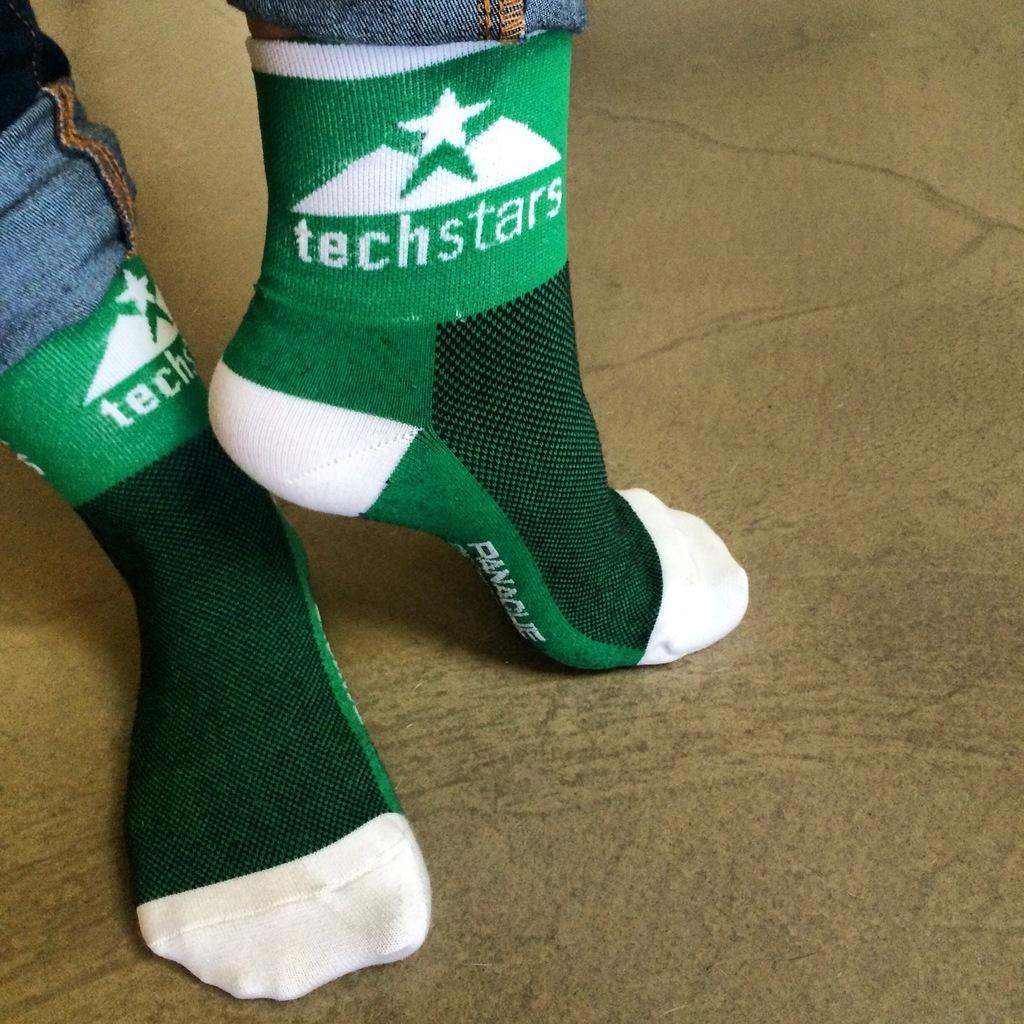Can you describe this image briefly? In this picture, we can see person legs covered with pants, socks and we can see the ground. 